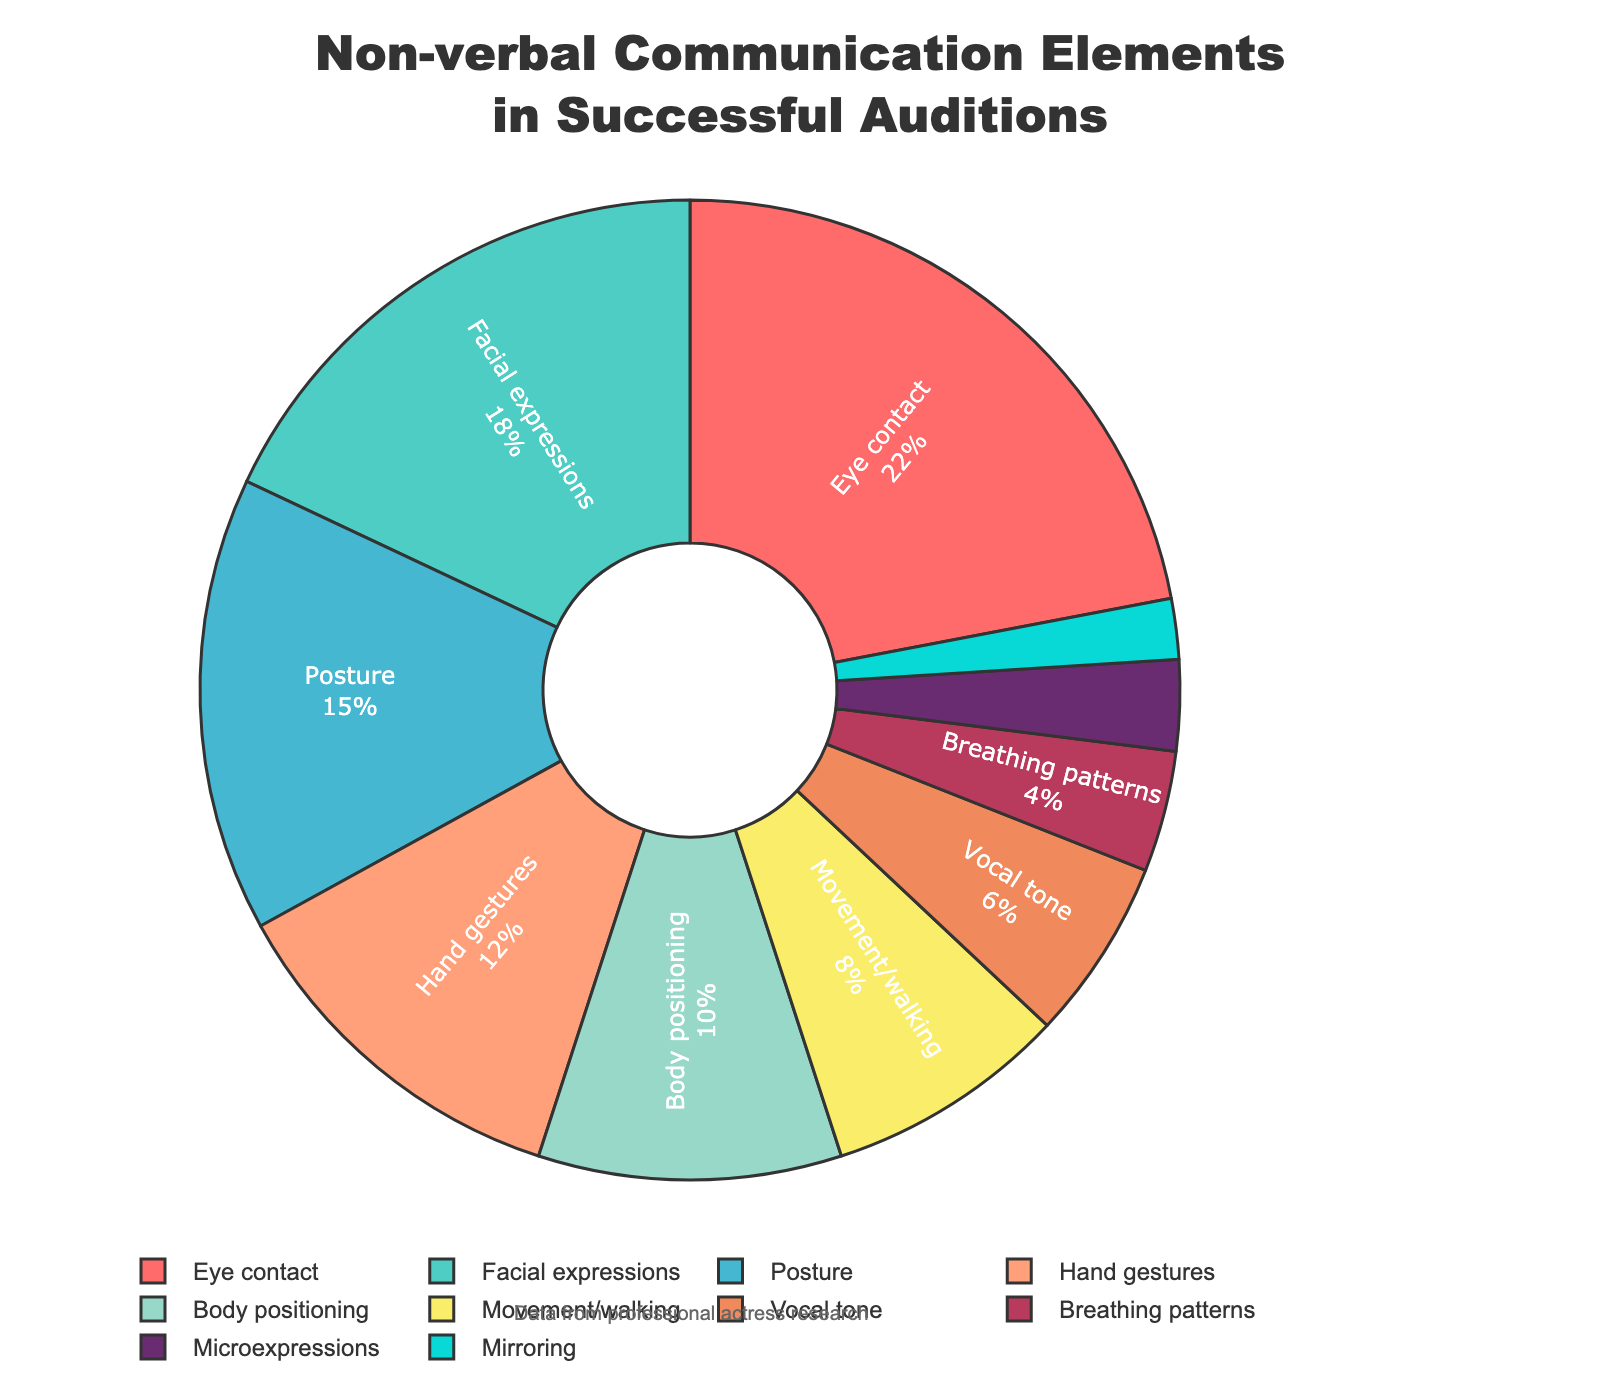What is the most significant element in successful auditions? By looking at the pie chart, the segment labeled "Eye contact" occupies the largest portion. This indicates it has the highest percentage.
Answer: Eye contact Which element has a higher percentage: Posture or Hand gestures? By examining the sizes of the segments labeled "Posture" and "Hand gestures," we see that "Posture" is slightly larger than "Hand gestures," indicating a higher percentage.
Answer: Posture What is the combined percentage of Body positioning and Movement/walking? The slices labeled "Body positioning" and "Movement/walking" represent 10% and 8% respectively. Adding these gives 10 + 8 = 18.
Answer: 18% How does the percentage of Facial expressions compare to Vocal tone? Looking at the sizes of the respective slices, "Facial expressions" has a significantly larger segment than "Vocal tone." This indicates that "Facial expressions" has a higher percentage.
Answer: Facial expressions Which element has the smallest contribution to non-verbal communication in successful auditions? The smallest slice in the pie chart is labeled "Mirroring," indicating it has the lowest percentage.
Answer: Mirroring Calculate the average percentage of all elements shown in the pie chart. Summing up all the percentages of the given elements: 22 + 18 + 15 + 12 + 10 + 8 + 6 + 4 + 3 + 2 = 100. Dividing the total by the number of elements (10) gives us 100/10 = 10.
Answer: 10% Is the percentage of Breathing patterns greater than Mirroring and Microexpressions combined? Breathing patterns account for 4%. Mirroring and Microexpressions combine to 2 + 3 = 5%. Since 4% is less than 5%, Breathing patterns is not greater.
Answer: No What is the difference in percentage between Eye contact and Microexpressions? Eye contact is 22% and Microexpressions is 3%. The difference is 22 - 3 = 19.
Answer: 19% Which element, between Body positioning and Hand gestures, constitutes a larger part of non-verbal communication in successful auditions? Comparing the segments, "Body positioning" has 10% while "Hand gestures" has 12%, indicating "Hand gestures" has a larger part.
Answer: Hand gestures 